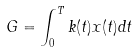<formula> <loc_0><loc_0><loc_500><loc_500>G = \int _ { 0 } ^ { T } k ( t ) x ( t ) d t</formula> 